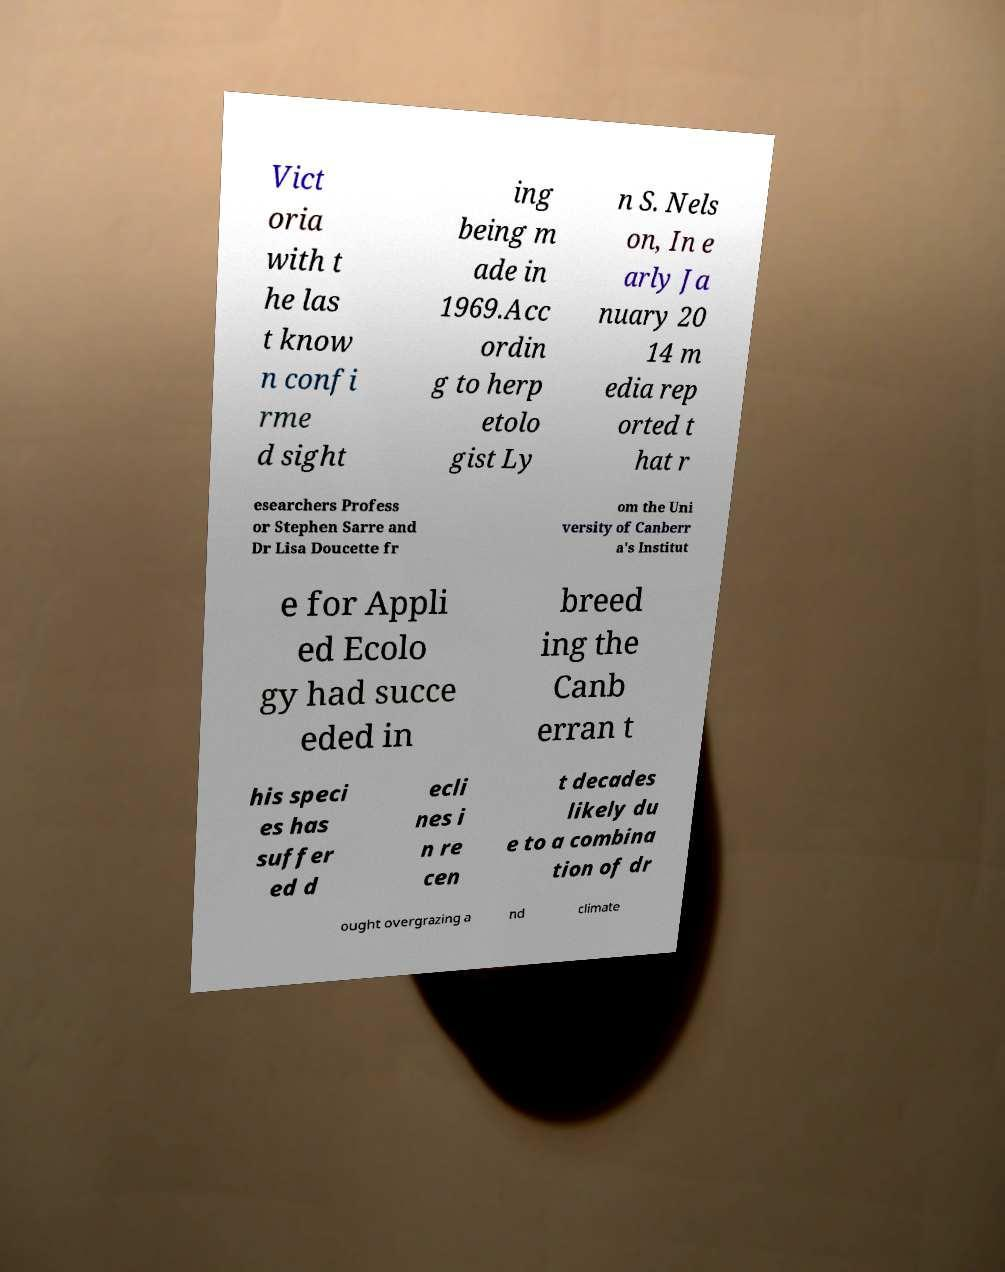I need the written content from this picture converted into text. Can you do that? Vict oria with t he las t know n confi rme d sight ing being m ade in 1969.Acc ordin g to herp etolo gist Ly n S. Nels on, In e arly Ja nuary 20 14 m edia rep orted t hat r esearchers Profess or Stephen Sarre and Dr Lisa Doucette fr om the Uni versity of Canberr a's Institut e for Appli ed Ecolo gy had succe eded in breed ing the Canb erran t his speci es has suffer ed d ecli nes i n re cen t decades likely du e to a combina tion of dr ought overgrazing a nd climate 